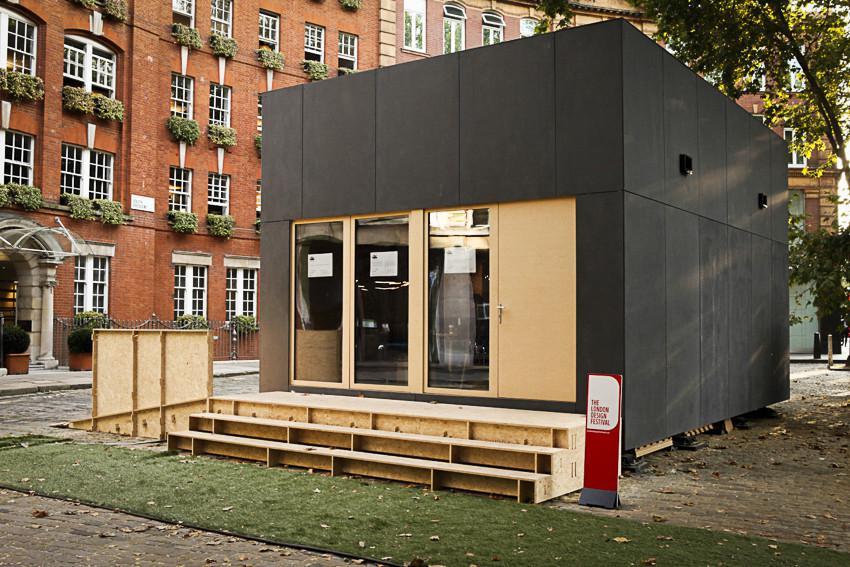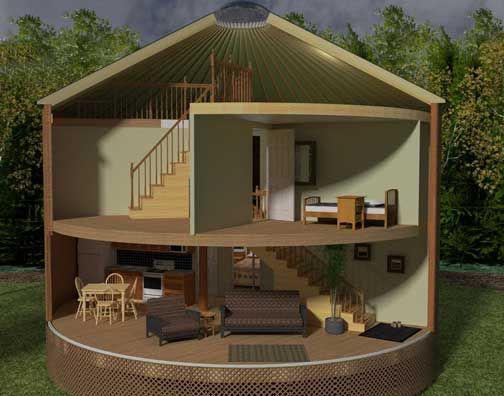The first image is the image on the left, the second image is the image on the right. Evaluate the accuracy of this statement regarding the images: "All images show only the exteriors of homes.". Is it true? Answer yes or no. No. 